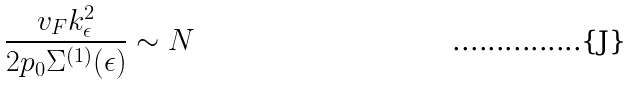<formula> <loc_0><loc_0><loc_500><loc_500>\frac { v _ { F } k _ { \epsilon } ^ { 2 } } { 2 p _ { 0 } \Sigma ^ { ( 1 ) } ( \epsilon ) } \sim N</formula> 